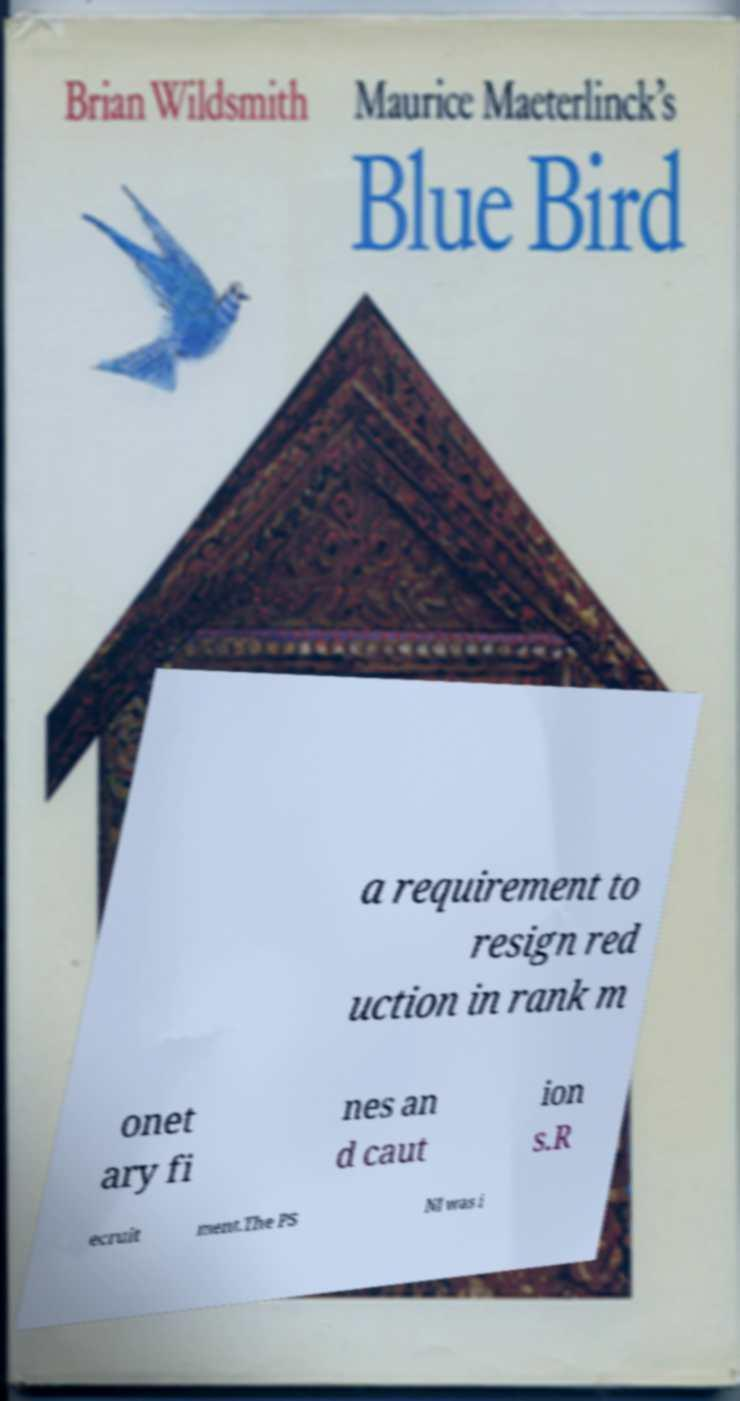Please identify and transcribe the text found in this image. a requirement to resign red uction in rank m onet ary fi nes an d caut ion s.R ecruit ment.The PS NI was i 